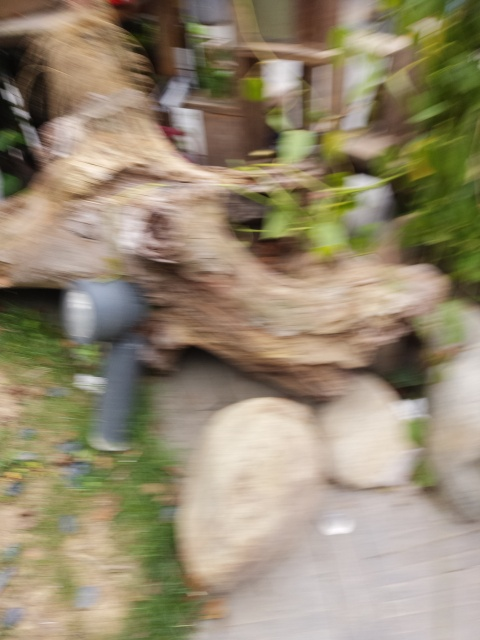Could there be any artistic reason for a photo like this to be taken intentionally? Artistically, a blurred image can convey a sense of motion, impermanence, or a dreamlike quality. Photographers sometimes use techniques like intentional camera movement or long exposure to create an abstract composition that focuses on color and form rather than detail, evoking feelings or an atmosphere rather than depicting a literal scene. 